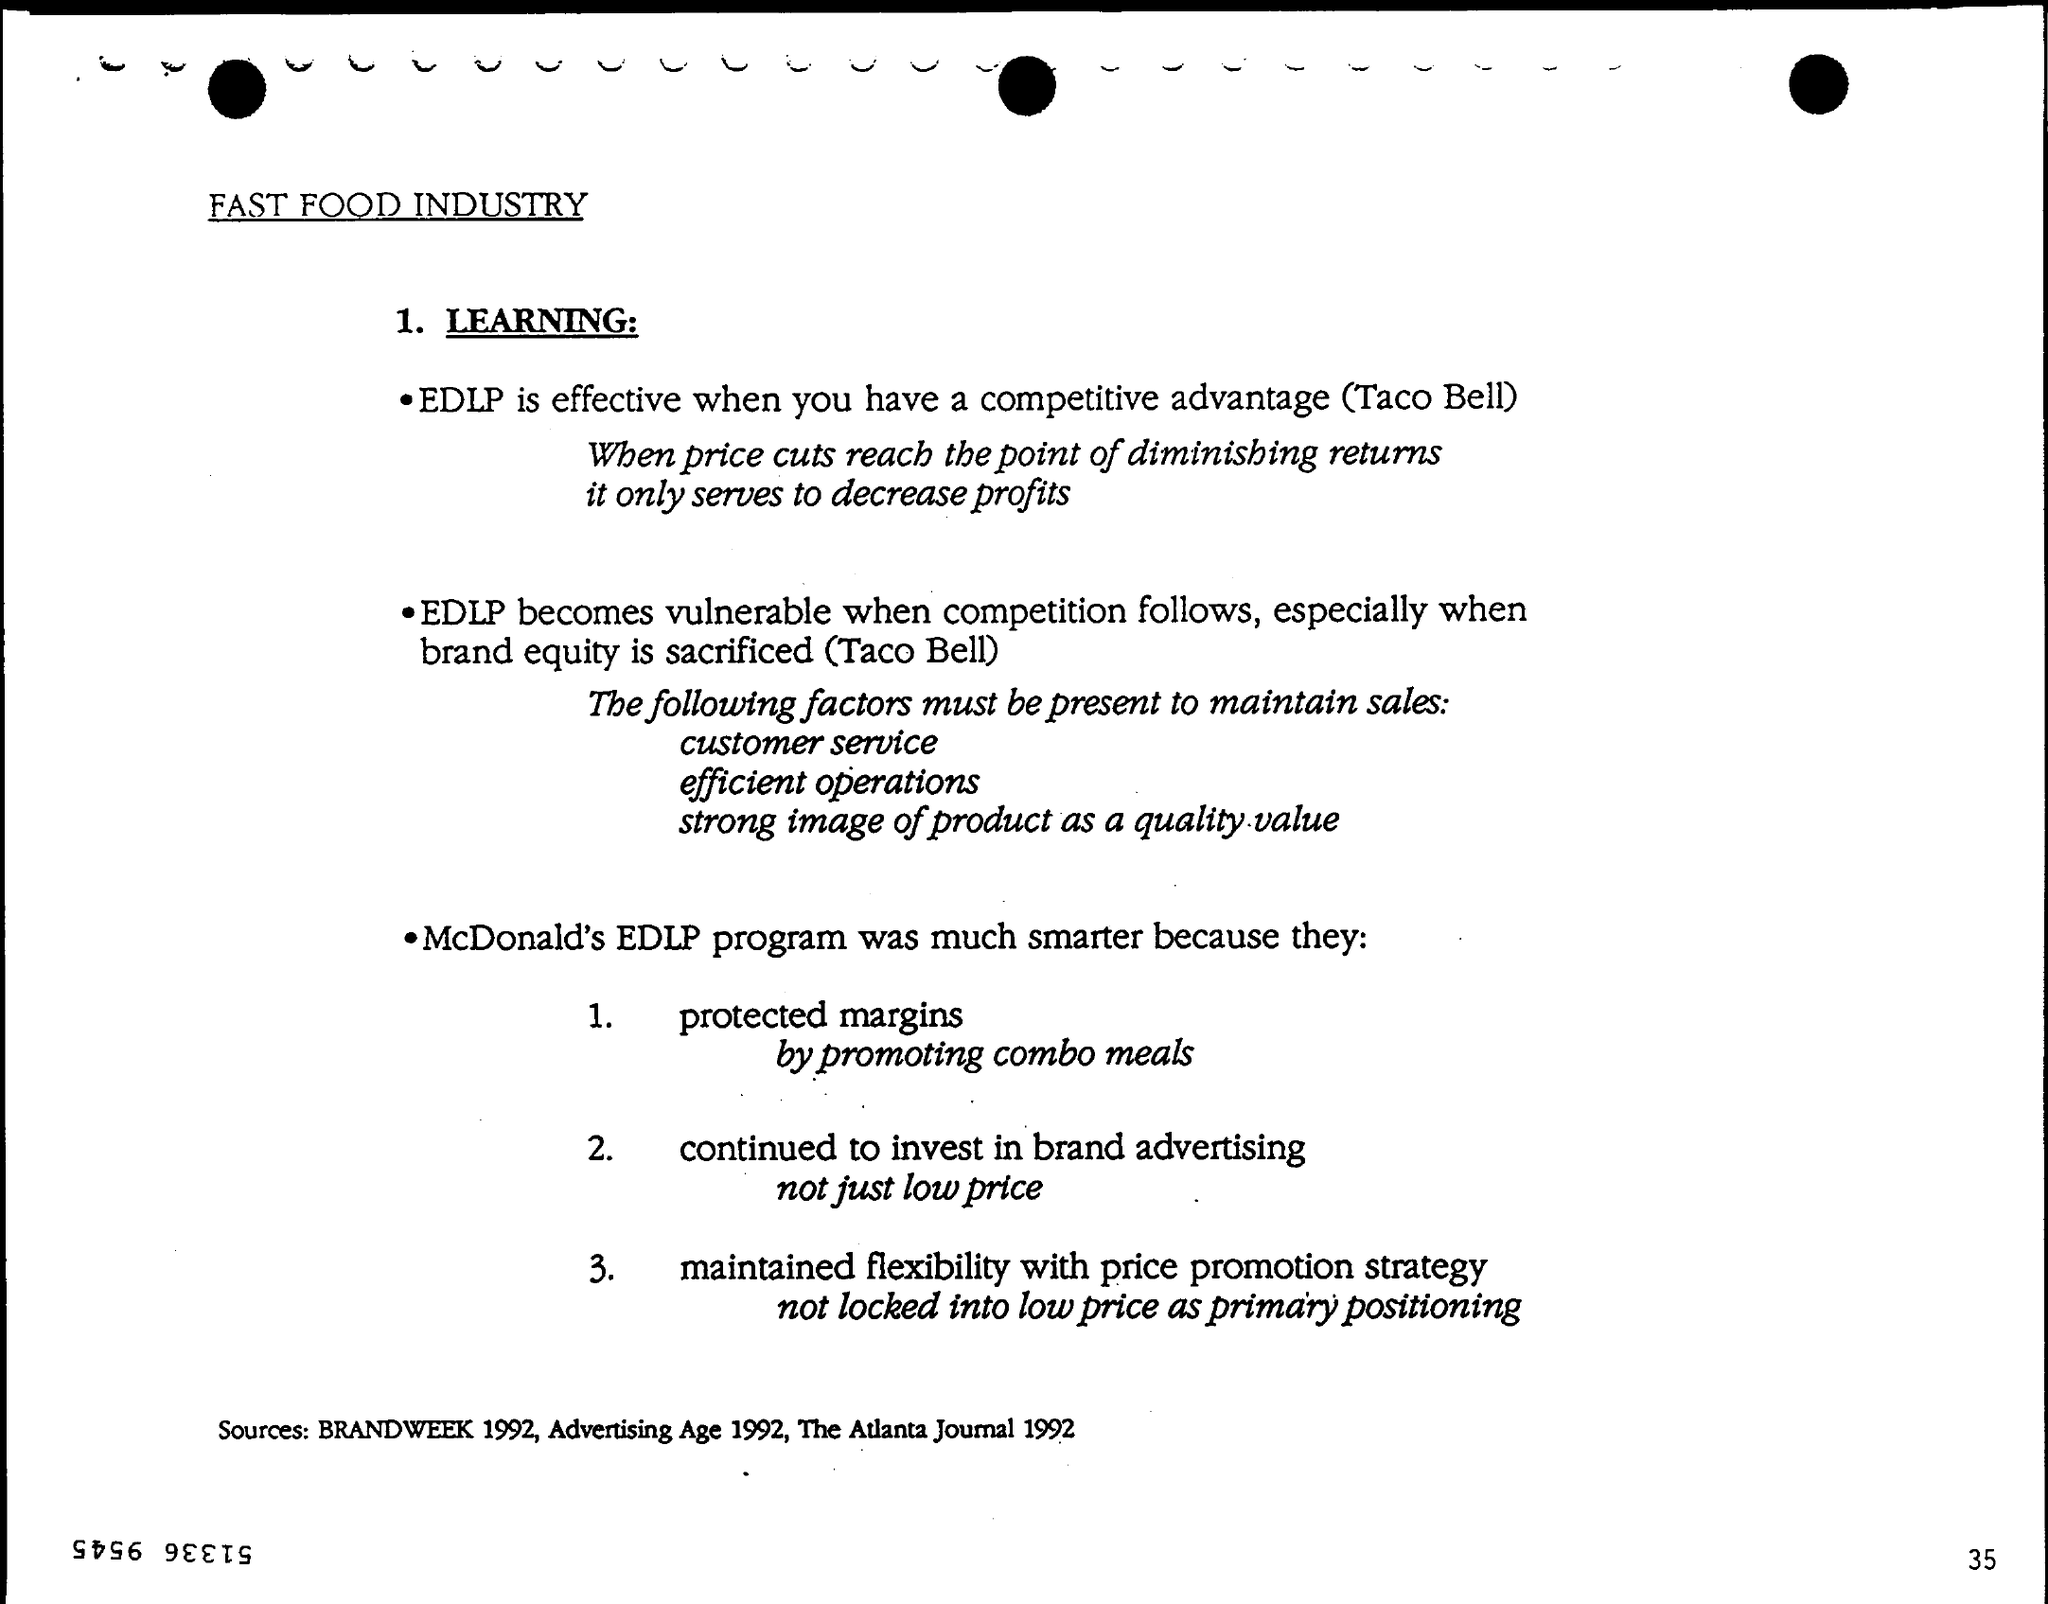How did McDonald's protect margins?
Your answer should be very brief. By promoting combo meals. What are the sources mentioned?
Your response must be concise. Brandweek 1992, Advertising Age 1992, The atlanta Journal 1992. 